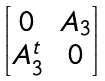Convert formula to latex. <formula><loc_0><loc_0><loc_500><loc_500>\begin{bmatrix} 0 & A _ { 3 } \\ A _ { 3 } ^ { t } & 0 \end{bmatrix}</formula> 